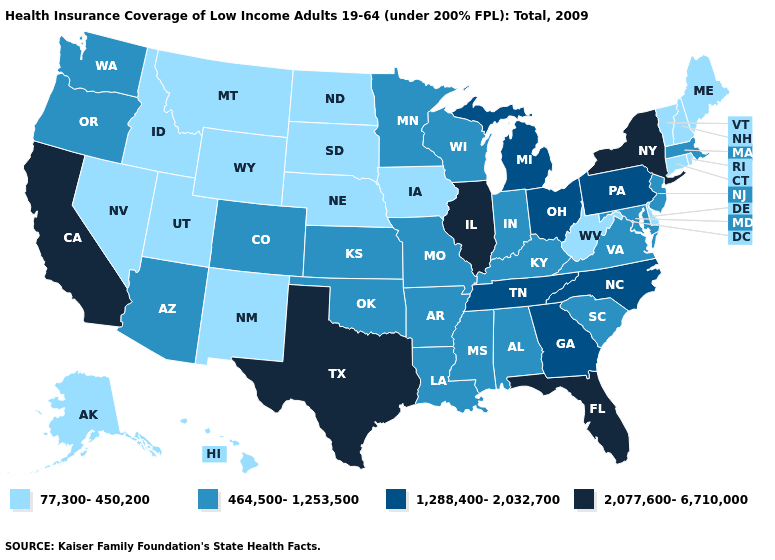Does Alaska have the lowest value in the USA?
Be succinct. Yes. What is the highest value in states that border South Carolina?
Give a very brief answer. 1,288,400-2,032,700. Among the states that border Ohio , does Pennsylvania have the highest value?
Give a very brief answer. Yes. Does Utah have a lower value than Minnesota?
Write a very short answer. Yes. Which states have the lowest value in the Northeast?
Write a very short answer. Connecticut, Maine, New Hampshire, Rhode Island, Vermont. Among the states that border Delaware , does Pennsylvania have the lowest value?
Concise answer only. No. What is the value of Ohio?
Be succinct. 1,288,400-2,032,700. What is the value of Vermont?
Quick response, please. 77,300-450,200. What is the highest value in states that border Alabama?
Be succinct. 2,077,600-6,710,000. What is the highest value in states that border South Carolina?
Quick response, please. 1,288,400-2,032,700. Name the states that have a value in the range 77,300-450,200?
Give a very brief answer. Alaska, Connecticut, Delaware, Hawaii, Idaho, Iowa, Maine, Montana, Nebraska, Nevada, New Hampshire, New Mexico, North Dakota, Rhode Island, South Dakota, Utah, Vermont, West Virginia, Wyoming. Name the states that have a value in the range 464,500-1,253,500?
Write a very short answer. Alabama, Arizona, Arkansas, Colorado, Indiana, Kansas, Kentucky, Louisiana, Maryland, Massachusetts, Minnesota, Mississippi, Missouri, New Jersey, Oklahoma, Oregon, South Carolina, Virginia, Washington, Wisconsin. Does Missouri have a lower value than Texas?
Quick response, please. Yes. What is the value of Vermont?
Keep it brief. 77,300-450,200. What is the highest value in the MidWest ?
Concise answer only. 2,077,600-6,710,000. 